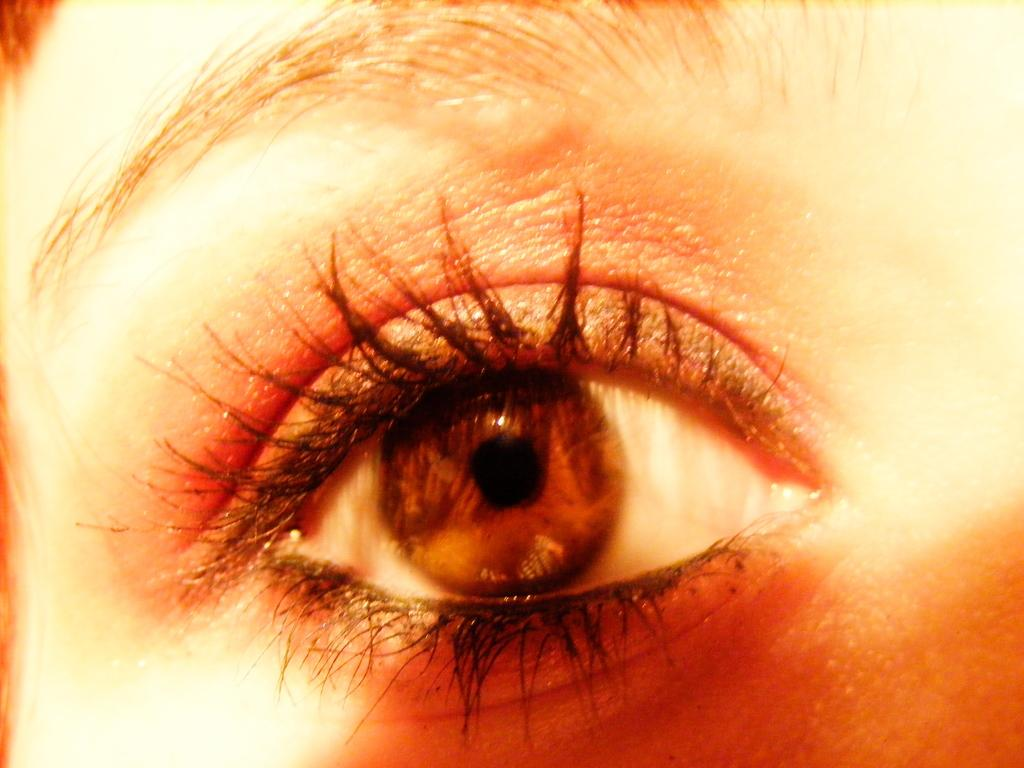What is the main subject of the image? There is a person in the image. What specific feature can be seen in the middle of the image? There is an eye in the middle of the image. What is located at the top of the image? There is an eyebrow at the top of the image. What invention is being demonstrated in the image? There is no invention being demonstrated in the image; it primarily features a person's eye and eyebrow. How many horns can be seen on the person's head in the image? There are no horns present on the person's head in the image. 